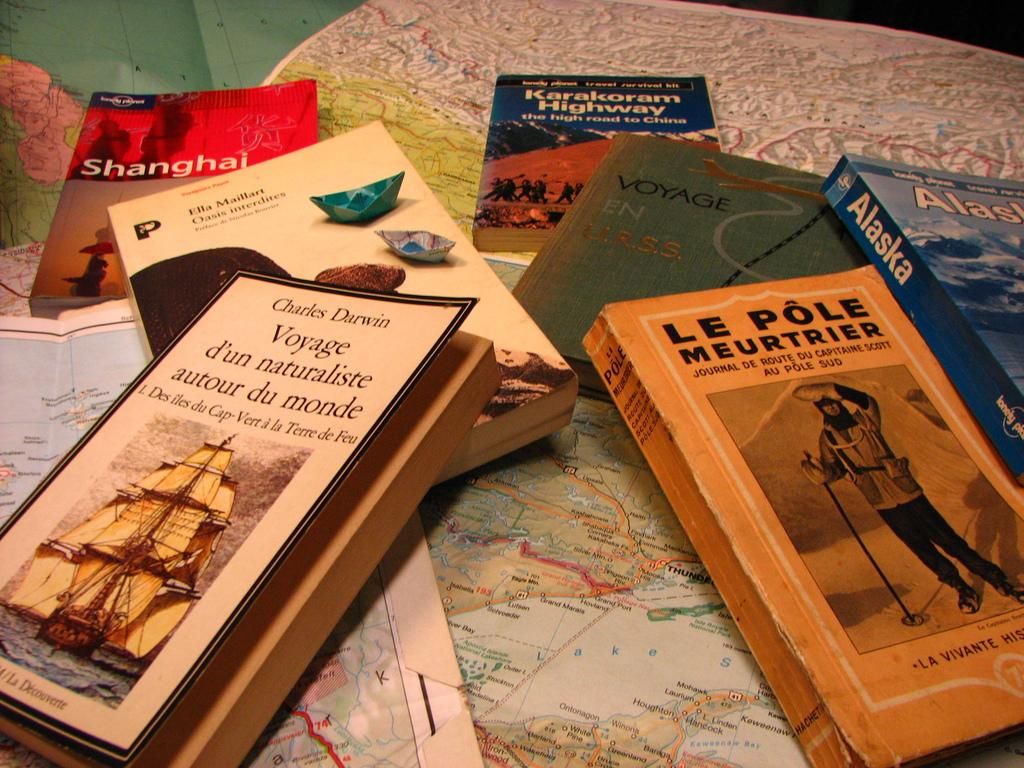<image>
Offer a succinct explanation of the picture presented. A Charles Darwin book sits in a pile with other books 